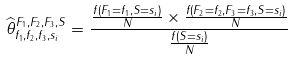<formula> <loc_0><loc_0><loc_500><loc_500>\widehat { \theta } _ { f _ { 1 } , f _ { 2 } , f _ { 3 } , s _ { i } } ^ { F _ { 1 } , F _ { 2 } , F _ { 3 } , S } = \frac { \frac { f ( F _ { 1 } = f _ { 1 } , S = s _ { i } ) } { N } \times \frac { f ( F _ { 2 } = f _ { 2 } , F _ { 3 } = f _ { 3 } , S = s _ { i } ) } { N } } { \frac { f ( S = s _ { i } ) } { N } }</formula> 